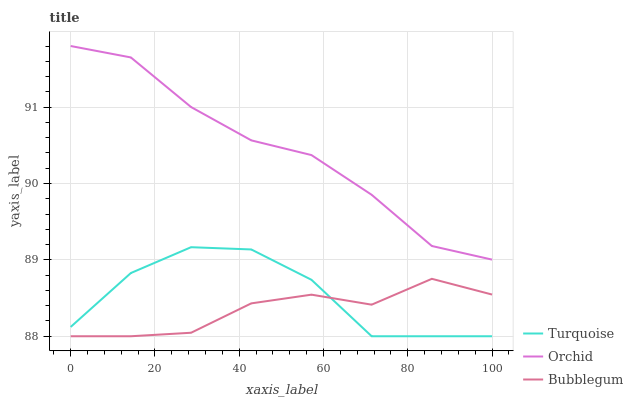Does Bubblegum have the minimum area under the curve?
Answer yes or no. Yes. Does Orchid have the maximum area under the curve?
Answer yes or no. Yes. Does Orchid have the minimum area under the curve?
Answer yes or no. No. Does Bubblegum have the maximum area under the curve?
Answer yes or no. No. Is Bubblegum the smoothest?
Answer yes or no. Yes. Is Turquoise the roughest?
Answer yes or no. Yes. Is Orchid the smoothest?
Answer yes or no. No. Is Orchid the roughest?
Answer yes or no. No. Does Orchid have the lowest value?
Answer yes or no. No. Does Orchid have the highest value?
Answer yes or no. Yes. Does Bubblegum have the highest value?
Answer yes or no. No. Is Bubblegum less than Orchid?
Answer yes or no. Yes. Is Orchid greater than Bubblegum?
Answer yes or no. Yes. Does Bubblegum intersect Turquoise?
Answer yes or no. Yes. Is Bubblegum less than Turquoise?
Answer yes or no. No. Is Bubblegum greater than Turquoise?
Answer yes or no. No. Does Bubblegum intersect Orchid?
Answer yes or no. No. 